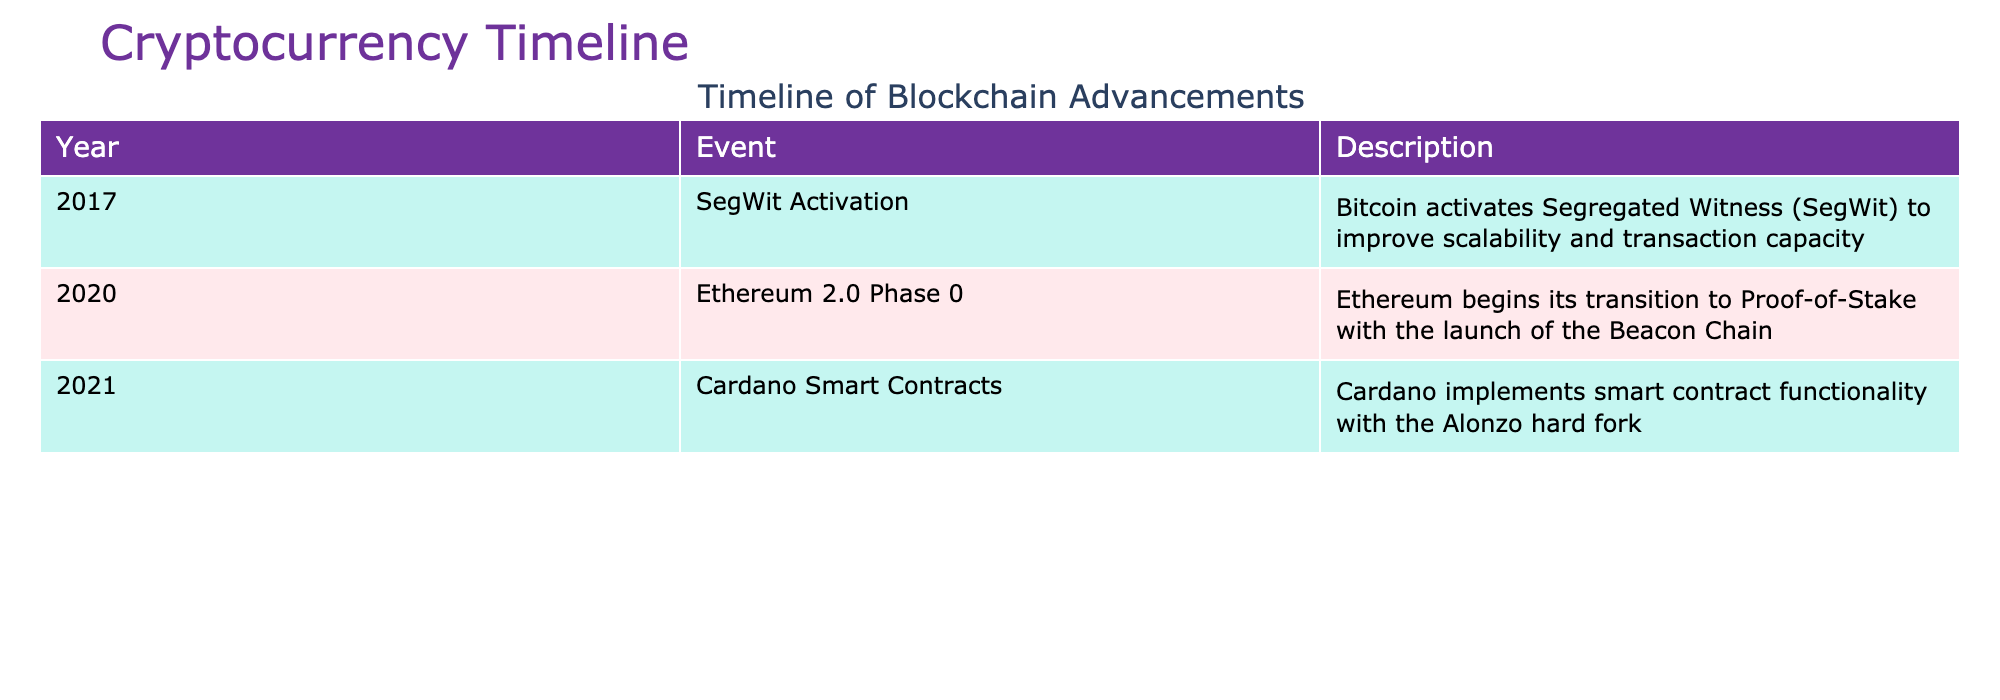What year did Bitcoin activate Segregated Witness? The table lists the events chronologically. By scanning through the 'Year' column, I find that Bitcoin activated Segregated Witness in 2017.
Answer: 2017 What event marked Ethereum's transition to Proof-of-Stake? Looking at the 'Event' column, I see that Ethereum 2.0 Phase 0 signifies its beginning transition to Proof-of-Stake.
Answer: Ethereum 2.0 Phase 0 How many blockchain advancements occurred in the year 2021? Referring to the 'Year' column, I see that there is one event listed for 2021, which is Cardano Smart Contracts.
Answer: 1 Did Cardano implement smart contract functionality before 2021? By examining the 'Year' column, I note that the Cardano Smart Contracts event took place in 2021; therefore, it was not implemented before that year.
Answer: No Which blockchain advancement happened immediately after SegWit activation? The table lists events chronologically, so I look for the event that follows 2017. The next event is Ethereum 2.0 Phase 0 in 2020, which happened after SegWit.
Answer: Ethereum 2.0 Phase 0 What is the average number of advancements per year between 2017 and 2021 based on the table? There are three events listed from 2017 to 2021. Therefore, to find the average, I divide the total number of events (3) by the number of years (5), which gives an average of 0.6 events per year.
Answer: 0.6 Was SegWit activation the first event listed in the table? By checking the 'Event' column, I see that SegWit Activation in 2017 is the earliest recorded event in this timeline, confirming it is the first.
Answer: Yes Which event in the timeline focused on improving scalability? Referring back to the 'Description' of events, SegWit Activation explicitly mentions an improvement in scalability and transaction capacity for Bitcoin.
Answer: SegWit Activation 